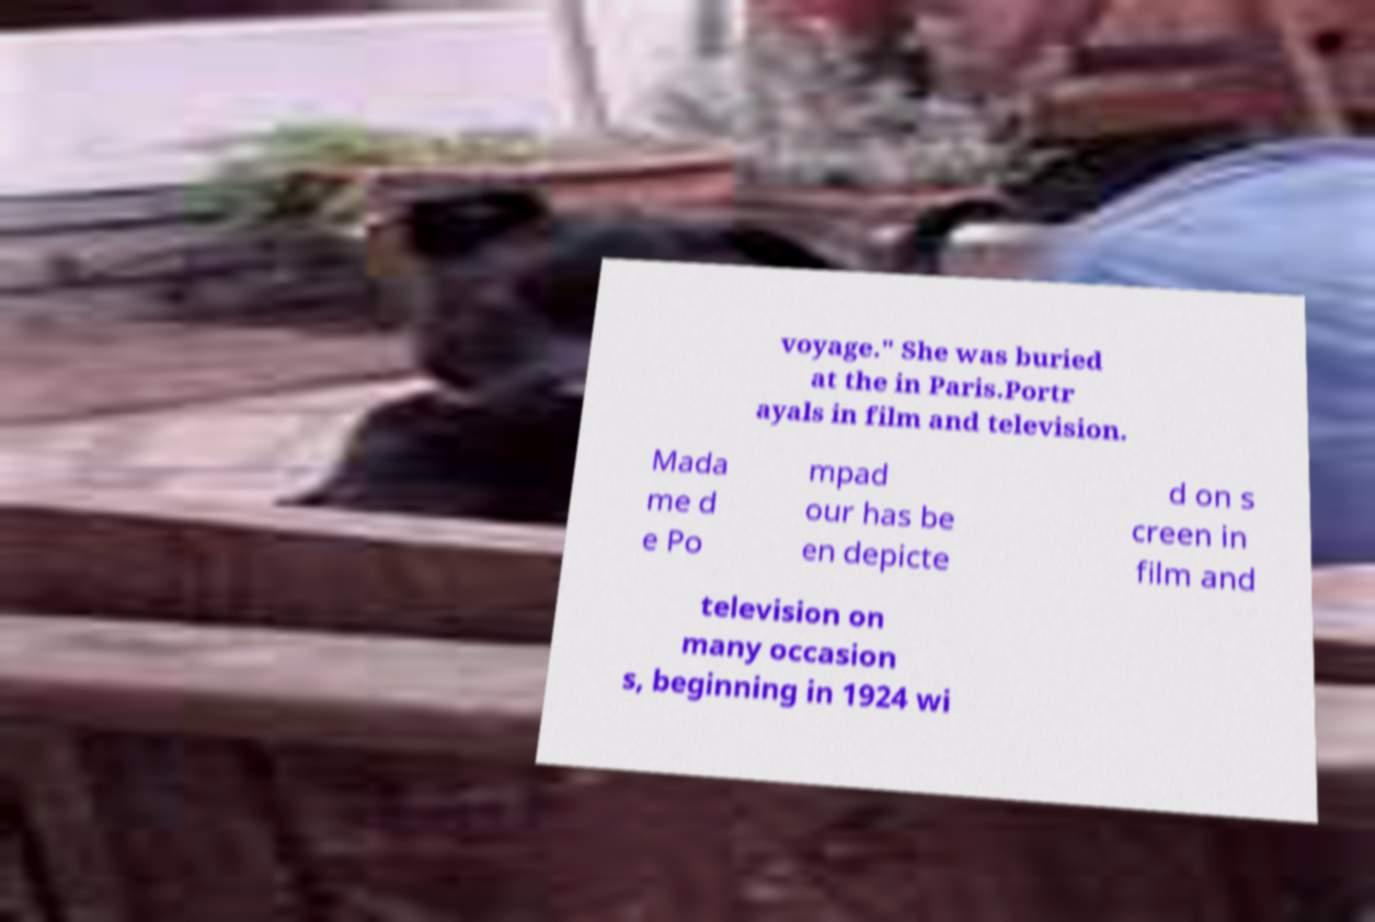Could you extract and type out the text from this image? voyage." She was buried at the in Paris.Portr ayals in film and television. Mada me d e Po mpad our has be en depicte d on s creen in film and television on many occasion s, beginning in 1924 wi 